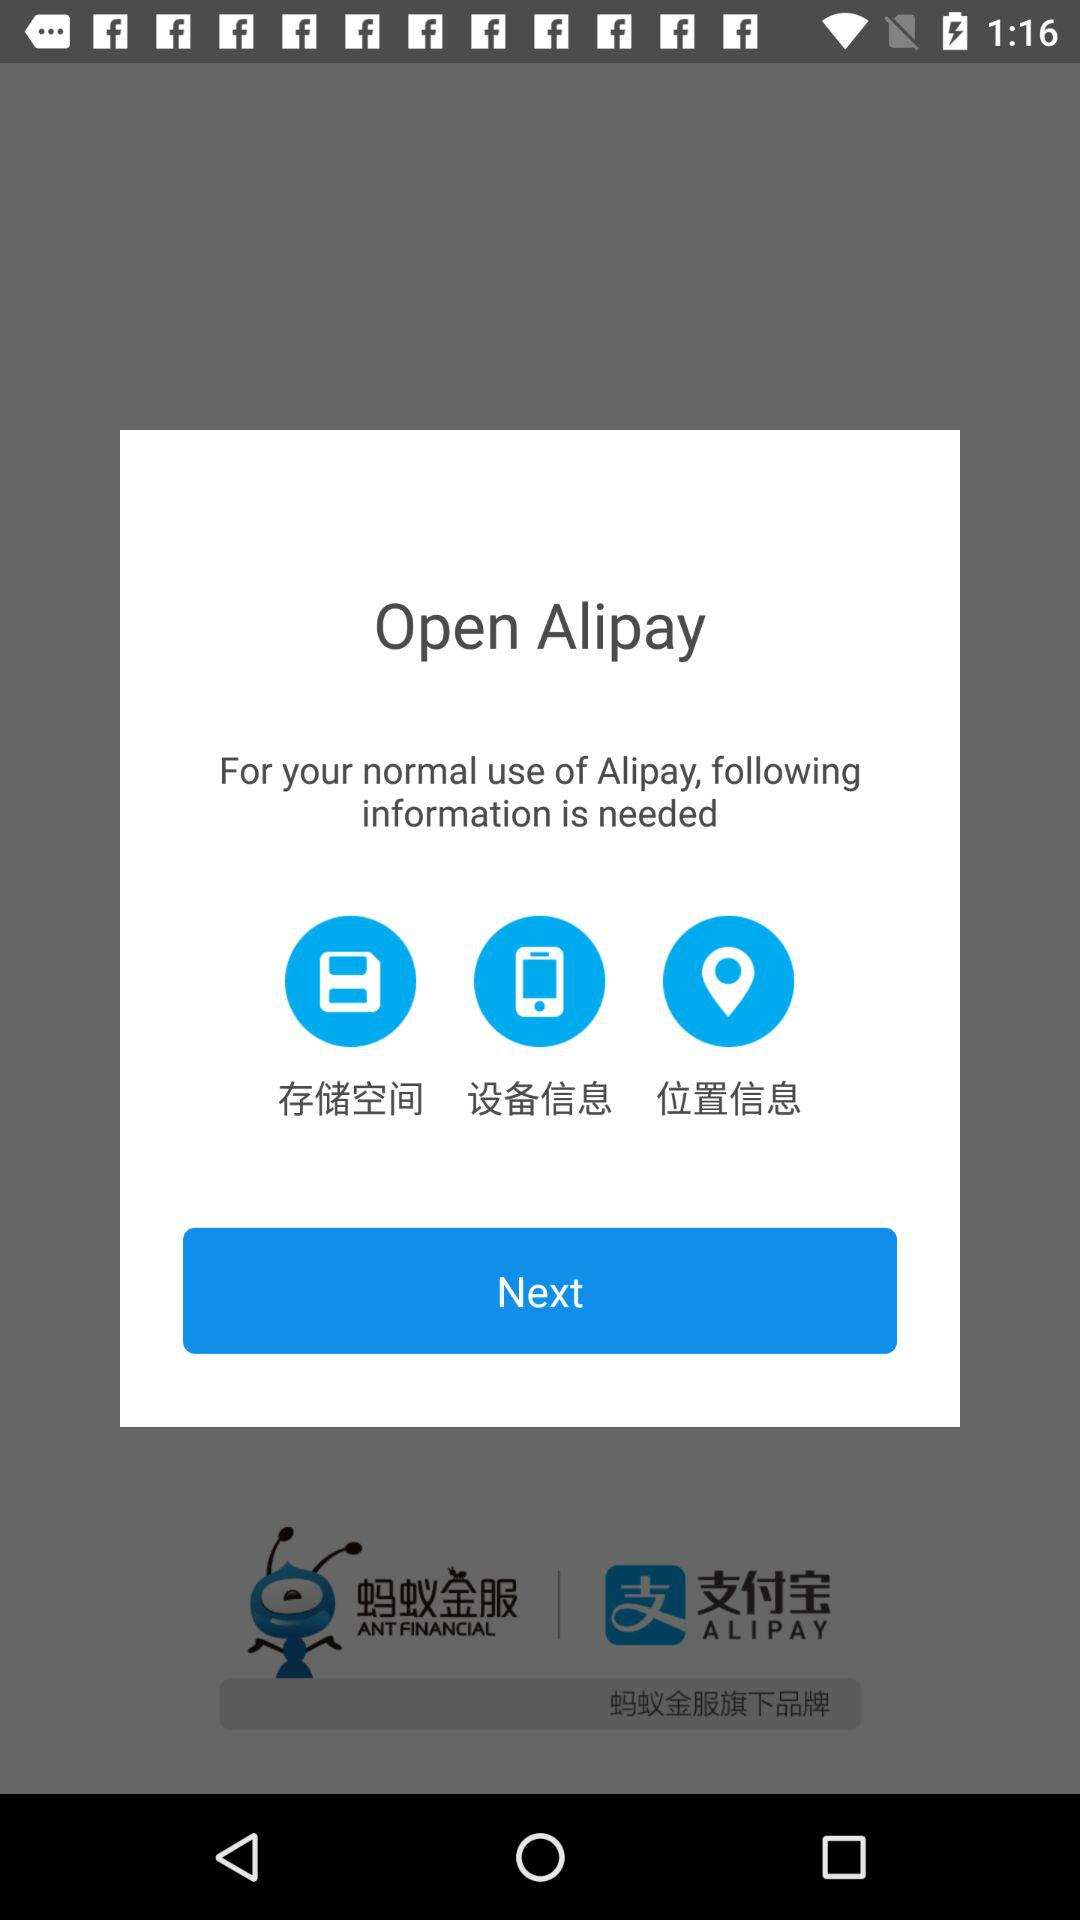How many types of data are needed to use Alipay?
Answer the question using a single word or phrase. 3 